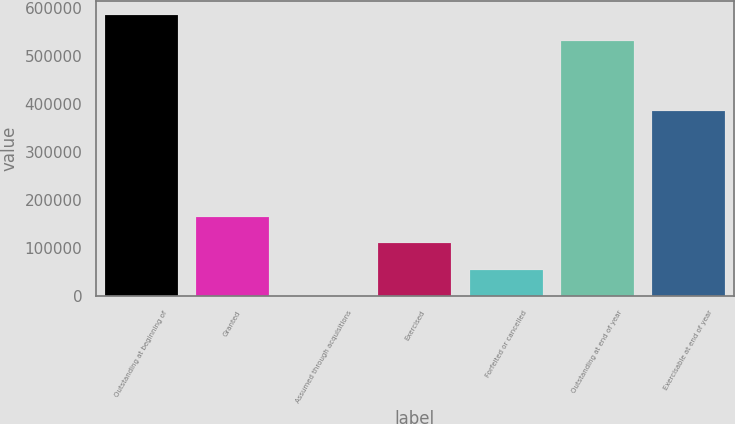Convert chart. <chart><loc_0><loc_0><loc_500><loc_500><bar_chart><fcel>Outstanding at beginning of<fcel>Granted<fcel>Assumed through acquisitions<fcel>Exercised<fcel>Forfeited or cancelled<fcel>Outstanding at end of year<fcel>Exercisable at end of year<nl><fcel>586164<fcel>165351<fcel>558<fcel>110420<fcel>55489<fcel>531233<fcel>386303<nl></chart> 